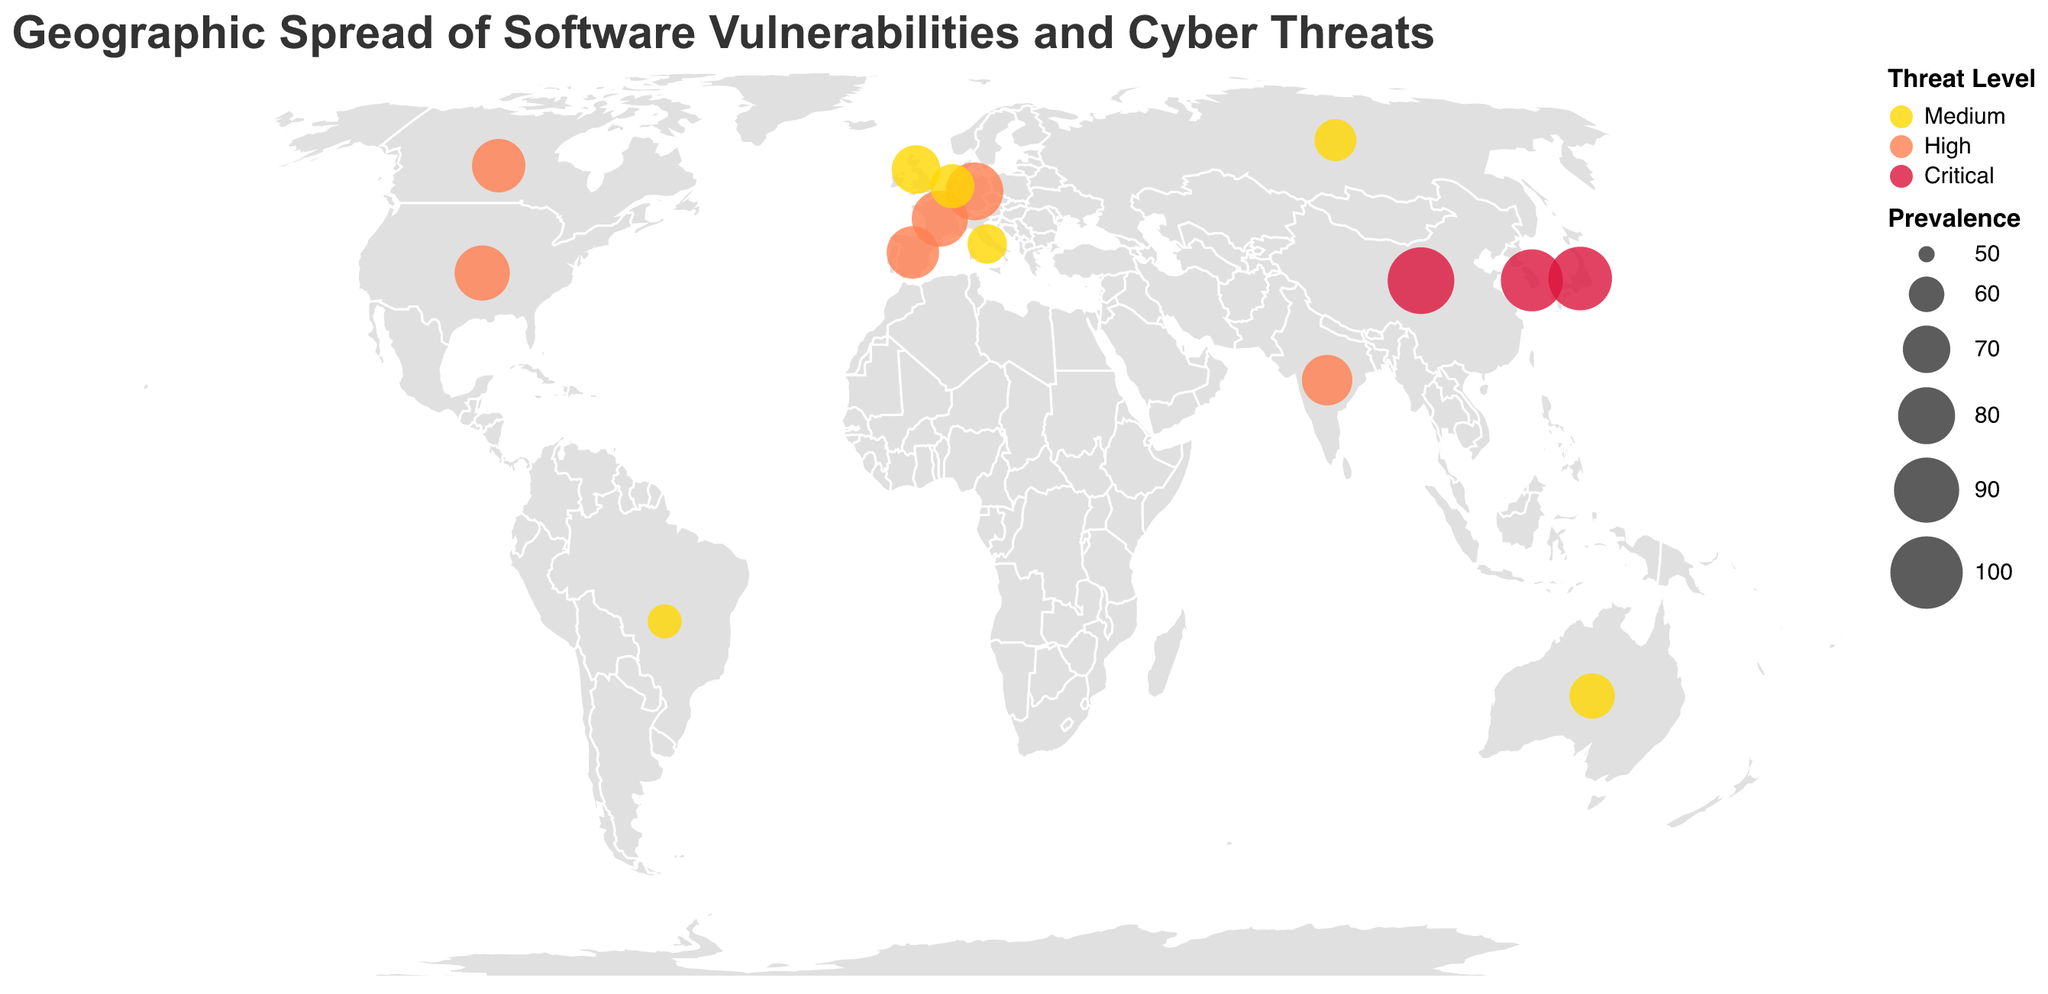How many countries are represented in the figure? Count the number of unique data points in the figure. Each circle represents a unique country, and there are 15 circles.
Answer: 15 Which country has the highest prevalence of a software vulnerability? Look for the circle with the largest size. The largest circle represents China, with a prevalence of 92.
Answer: China What is the average prevalence of 'Medium' threat level vulnerabilities? Identify the countries with 'Medium' threat levels, which are Russia, Brazil, United Kingdom, Australia, Italy, and Netherlands. The prevalences are 65, 59, 71, 68, 63, and 67. Calculate the average: (65+59+71+68+63+67)/6 = 65.5.
Answer: 65.5 Which threat level has the most countries associated with it? Count the number of countries for each threat level. 'Medium' has 6 countries, 'High' has 6 countries, and 'Critical' has 3 countries. Both 'Medium' and 'High' are tied, each with 6 countries.
Answer: Medium and High What cyber threat is most prevalent in the United States? Check the tooltip for the USA's circle to find the vulnerability, which is SQL Injection.
Answer: SQL Injection Which two countries have the closest prevalence values, and what are those values? Compare the prevalence of each country and find the smallest difference. United Kingdom (71) and Spain (75) have the closest prevalence values, with a difference of 4.
Answer: United Kingdom (71) and Spain (75) What is the most common type of software vulnerability in terms of threat level 'High'? Filter the countries with 'High' threat levels. The vulnerabilities for these countries are SQL Injection, Buffer Overflow, Denial of Service, Zero-Day Exploit, Privilege Escalation, and Unpatched Systems. No single type is repeated, so there is no most common type.
Answer: None (all unique) How many critical threats are represented in the figure, and what are they? Count the countries with 'Critical' threat levels and list the associated vulnerabilities. There are 3 critical threats: Remote Code Execution, Ransomware, and Data Breach.
Answer: 3, Remote Code Execution, Ransomware, Data Breach Are there more countries with 'Medium' threat levels or 'Critical' threat levels? Count the circles for each threat level. 'Medium' has 6 countries, and 'Critical' has 3 countries. Therefore, there are more countries with 'Medium' threat levels.
Answer: Medium What is the prevalence range of 'High' threat levels, and which countries fall into this range? Identify the countries with 'High' threat levels and note their prevalences: United States (78), India (73), Germany (81), Canada (76), France (79), and Spain (75). The range is from the lowest (73 in India) to the highest (81 in Germany).
Answer: 73-81, United States, India, Germany, Canada, France, Spain 